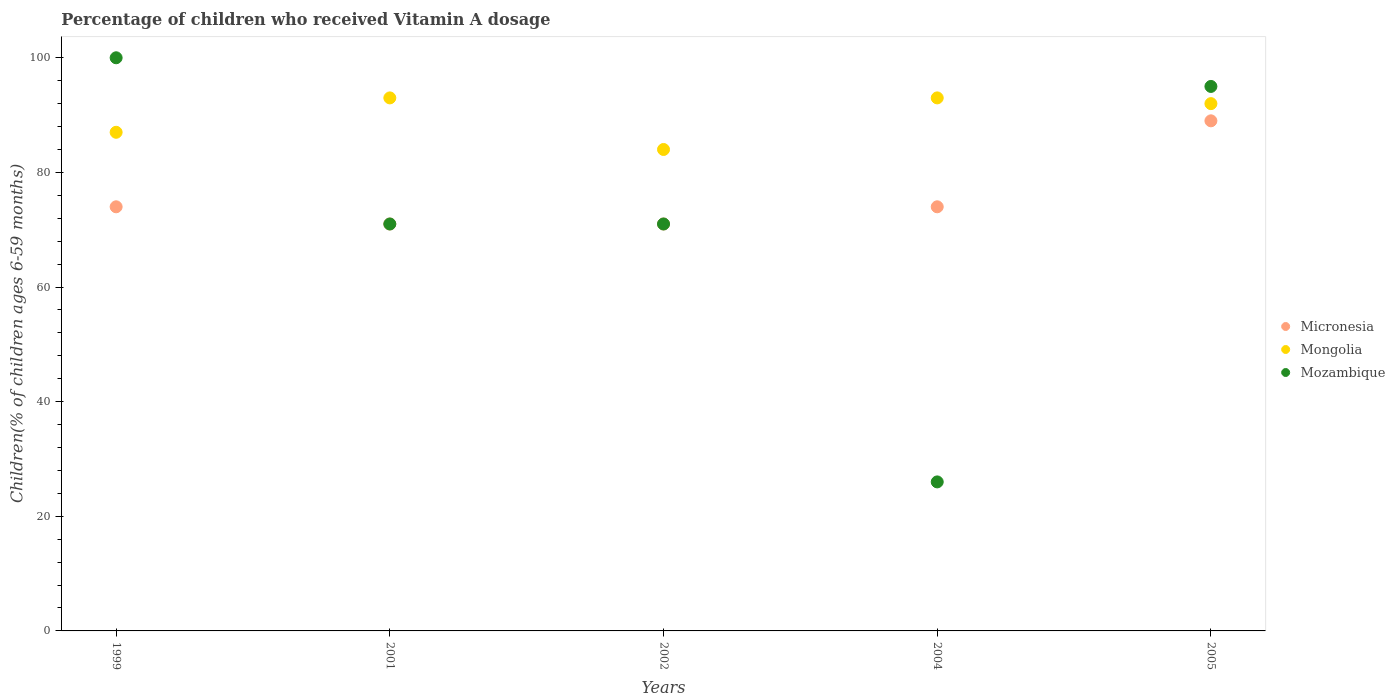Across all years, what is the maximum percentage of children who received Vitamin A dosage in Mongolia?
Ensure brevity in your answer.  93. In which year was the percentage of children who received Vitamin A dosage in Mozambique maximum?
Give a very brief answer. 1999. What is the total percentage of children who received Vitamin A dosage in Mongolia in the graph?
Provide a succinct answer. 449. What is the average percentage of children who received Vitamin A dosage in Mongolia per year?
Keep it short and to the point. 89.8. What is the ratio of the percentage of children who received Vitamin A dosage in Micronesia in 2002 to that in 2005?
Offer a terse response. 0.8. Is the percentage of children who received Vitamin A dosage in Mongolia in 1999 less than that in 2005?
Your answer should be very brief. Yes. Is the difference between the percentage of children who received Vitamin A dosage in Mozambique in 2002 and 2005 greater than the difference between the percentage of children who received Vitamin A dosage in Mongolia in 2002 and 2005?
Your answer should be very brief. No. What is the difference between the highest and the second highest percentage of children who received Vitamin A dosage in Micronesia?
Ensure brevity in your answer.  15. What is the difference between the highest and the lowest percentage of children who received Vitamin A dosage in Mozambique?
Offer a terse response. 74. Does the percentage of children who received Vitamin A dosage in Mongolia monotonically increase over the years?
Keep it short and to the point. No. How many dotlines are there?
Offer a terse response. 3. How many years are there in the graph?
Ensure brevity in your answer.  5. Are the values on the major ticks of Y-axis written in scientific E-notation?
Offer a very short reply. No. Does the graph contain any zero values?
Your answer should be compact. No. How are the legend labels stacked?
Your answer should be very brief. Vertical. What is the title of the graph?
Make the answer very short. Percentage of children who received Vitamin A dosage. Does "Korea (Republic)" appear as one of the legend labels in the graph?
Make the answer very short. No. What is the label or title of the X-axis?
Offer a terse response. Years. What is the label or title of the Y-axis?
Offer a very short reply. Children(% of children ages 6-59 months). What is the Children(% of children ages 6-59 months) of Mozambique in 1999?
Provide a short and direct response. 100. What is the Children(% of children ages 6-59 months) of Mongolia in 2001?
Your answer should be very brief. 93. What is the Children(% of children ages 6-59 months) in Mozambique in 2001?
Offer a terse response. 71. What is the Children(% of children ages 6-59 months) in Micronesia in 2002?
Provide a short and direct response. 71. What is the Children(% of children ages 6-59 months) in Micronesia in 2004?
Your answer should be compact. 74. What is the Children(% of children ages 6-59 months) in Mongolia in 2004?
Keep it short and to the point. 93. What is the Children(% of children ages 6-59 months) in Mozambique in 2004?
Your response must be concise. 26. What is the Children(% of children ages 6-59 months) of Micronesia in 2005?
Give a very brief answer. 89. What is the Children(% of children ages 6-59 months) of Mongolia in 2005?
Make the answer very short. 92. What is the Children(% of children ages 6-59 months) in Mozambique in 2005?
Ensure brevity in your answer.  95. Across all years, what is the maximum Children(% of children ages 6-59 months) of Micronesia?
Your answer should be very brief. 89. Across all years, what is the maximum Children(% of children ages 6-59 months) of Mongolia?
Keep it short and to the point. 93. Across all years, what is the maximum Children(% of children ages 6-59 months) of Mozambique?
Offer a terse response. 100. Across all years, what is the minimum Children(% of children ages 6-59 months) of Micronesia?
Your response must be concise. 71. Across all years, what is the minimum Children(% of children ages 6-59 months) of Mozambique?
Your answer should be very brief. 26. What is the total Children(% of children ages 6-59 months) of Micronesia in the graph?
Your answer should be very brief. 379. What is the total Children(% of children ages 6-59 months) of Mongolia in the graph?
Give a very brief answer. 449. What is the total Children(% of children ages 6-59 months) of Mozambique in the graph?
Ensure brevity in your answer.  363. What is the difference between the Children(% of children ages 6-59 months) in Micronesia in 1999 and that in 2001?
Ensure brevity in your answer.  3. What is the difference between the Children(% of children ages 6-59 months) of Mongolia in 1999 and that in 2001?
Your response must be concise. -6. What is the difference between the Children(% of children ages 6-59 months) of Mozambique in 1999 and that in 2002?
Provide a succinct answer. 29. What is the difference between the Children(% of children ages 6-59 months) of Mongolia in 1999 and that in 2004?
Make the answer very short. -6. What is the difference between the Children(% of children ages 6-59 months) of Mongolia in 1999 and that in 2005?
Offer a terse response. -5. What is the difference between the Children(% of children ages 6-59 months) in Micronesia in 2001 and that in 2002?
Provide a succinct answer. 0. What is the difference between the Children(% of children ages 6-59 months) of Micronesia in 2001 and that in 2004?
Offer a very short reply. -3. What is the difference between the Children(% of children ages 6-59 months) of Mongolia in 2001 and that in 2004?
Your answer should be very brief. 0. What is the difference between the Children(% of children ages 6-59 months) in Micronesia in 2002 and that in 2004?
Keep it short and to the point. -3. What is the difference between the Children(% of children ages 6-59 months) of Mozambique in 2002 and that in 2004?
Provide a short and direct response. 45. What is the difference between the Children(% of children ages 6-59 months) in Micronesia in 2002 and that in 2005?
Provide a short and direct response. -18. What is the difference between the Children(% of children ages 6-59 months) in Mongolia in 2002 and that in 2005?
Give a very brief answer. -8. What is the difference between the Children(% of children ages 6-59 months) of Mozambique in 2004 and that in 2005?
Your answer should be very brief. -69. What is the difference between the Children(% of children ages 6-59 months) in Micronesia in 1999 and the Children(% of children ages 6-59 months) in Mongolia in 2001?
Offer a terse response. -19. What is the difference between the Children(% of children ages 6-59 months) in Micronesia in 1999 and the Children(% of children ages 6-59 months) in Mozambique in 2001?
Give a very brief answer. 3. What is the difference between the Children(% of children ages 6-59 months) in Mongolia in 1999 and the Children(% of children ages 6-59 months) in Mozambique in 2001?
Provide a succinct answer. 16. What is the difference between the Children(% of children ages 6-59 months) of Micronesia in 1999 and the Children(% of children ages 6-59 months) of Mongolia in 2002?
Offer a terse response. -10. What is the difference between the Children(% of children ages 6-59 months) of Mongolia in 1999 and the Children(% of children ages 6-59 months) of Mozambique in 2004?
Provide a succinct answer. 61. What is the difference between the Children(% of children ages 6-59 months) of Micronesia in 1999 and the Children(% of children ages 6-59 months) of Mongolia in 2005?
Provide a short and direct response. -18. What is the difference between the Children(% of children ages 6-59 months) of Micronesia in 2001 and the Children(% of children ages 6-59 months) of Mongolia in 2002?
Keep it short and to the point. -13. What is the difference between the Children(% of children ages 6-59 months) of Micronesia in 2001 and the Children(% of children ages 6-59 months) of Mozambique in 2002?
Give a very brief answer. 0. What is the difference between the Children(% of children ages 6-59 months) of Mongolia in 2001 and the Children(% of children ages 6-59 months) of Mozambique in 2002?
Offer a terse response. 22. What is the difference between the Children(% of children ages 6-59 months) in Micronesia in 2001 and the Children(% of children ages 6-59 months) in Mozambique in 2004?
Provide a succinct answer. 45. What is the difference between the Children(% of children ages 6-59 months) of Micronesia in 2001 and the Children(% of children ages 6-59 months) of Mongolia in 2005?
Give a very brief answer. -21. What is the difference between the Children(% of children ages 6-59 months) in Micronesia in 2001 and the Children(% of children ages 6-59 months) in Mozambique in 2005?
Provide a succinct answer. -24. What is the difference between the Children(% of children ages 6-59 months) in Mongolia in 2001 and the Children(% of children ages 6-59 months) in Mozambique in 2005?
Offer a terse response. -2. What is the difference between the Children(% of children ages 6-59 months) in Micronesia in 2002 and the Children(% of children ages 6-59 months) in Mongolia in 2004?
Make the answer very short. -22. What is the difference between the Children(% of children ages 6-59 months) of Micronesia in 2002 and the Children(% of children ages 6-59 months) of Mongolia in 2005?
Provide a succinct answer. -21. What is the difference between the Children(% of children ages 6-59 months) in Mongolia in 2002 and the Children(% of children ages 6-59 months) in Mozambique in 2005?
Give a very brief answer. -11. What is the average Children(% of children ages 6-59 months) of Micronesia per year?
Provide a succinct answer. 75.8. What is the average Children(% of children ages 6-59 months) in Mongolia per year?
Your response must be concise. 89.8. What is the average Children(% of children ages 6-59 months) in Mozambique per year?
Your answer should be compact. 72.6. In the year 2001, what is the difference between the Children(% of children ages 6-59 months) in Micronesia and Children(% of children ages 6-59 months) in Mongolia?
Your answer should be compact. -22. In the year 2001, what is the difference between the Children(% of children ages 6-59 months) in Mongolia and Children(% of children ages 6-59 months) in Mozambique?
Make the answer very short. 22. In the year 2002, what is the difference between the Children(% of children ages 6-59 months) in Micronesia and Children(% of children ages 6-59 months) in Mozambique?
Make the answer very short. 0. In the year 2004, what is the difference between the Children(% of children ages 6-59 months) of Micronesia and Children(% of children ages 6-59 months) of Mozambique?
Your answer should be very brief. 48. In the year 2004, what is the difference between the Children(% of children ages 6-59 months) of Mongolia and Children(% of children ages 6-59 months) of Mozambique?
Your response must be concise. 67. In the year 2005, what is the difference between the Children(% of children ages 6-59 months) in Micronesia and Children(% of children ages 6-59 months) in Mongolia?
Give a very brief answer. -3. In the year 2005, what is the difference between the Children(% of children ages 6-59 months) in Mongolia and Children(% of children ages 6-59 months) in Mozambique?
Ensure brevity in your answer.  -3. What is the ratio of the Children(% of children ages 6-59 months) in Micronesia in 1999 to that in 2001?
Your response must be concise. 1.04. What is the ratio of the Children(% of children ages 6-59 months) of Mongolia in 1999 to that in 2001?
Offer a very short reply. 0.94. What is the ratio of the Children(% of children ages 6-59 months) in Mozambique in 1999 to that in 2001?
Your answer should be very brief. 1.41. What is the ratio of the Children(% of children ages 6-59 months) of Micronesia in 1999 to that in 2002?
Offer a very short reply. 1.04. What is the ratio of the Children(% of children ages 6-59 months) of Mongolia in 1999 to that in 2002?
Keep it short and to the point. 1.04. What is the ratio of the Children(% of children ages 6-59 months) of Mozambique in 1999 to that in 2002?
Your answer should be very brief. 1.41. What is the ratio of the Children(% of children ages 6-59 months) of Micronesia in 1999 to that in 2004?
Keep it short and to the point. 1. What is the ratio of the Children(% of children ages 6-59 months) in Mongolia in 1999 to that in 2004?
Your answer should be compact. 0.94. What is the ratio of the Children(% of children ages 6-59 months) in Mozambique in 1999 to that in 2004?
Your response must be concise. 3.85. What is the ratio of the Children(% of children ages 6-59 months) in Micronesia in 1999 to that in 2005?
Give a very brief answer. 0.83. What is the ratio of the Children(% of children ages 6-59 months) of Mongolia in 1999 to that in 2005?
Your response must be concise. 0.95. What is the ratio of the Children(% of children ages 6-59 months) of Mozambique in 1999 to that in 2005?
Give a very brief answer. 1.05. What is the ratio of the Children(% of children ages 6-59 months) of Micronesia in 2001 to that in 2002?
Offer a very short reply. 1. What is the ratio of the Children(% of children ages 6-59 months) of Mongolia in 2001 to that in 2002?
Keep it short and to the point. 1.11. What is the ratio of the Children(% of children ages 6-59 months) in Mozambique in 2001 to that in 2002?
Keep it short and to the point. 1. What is the ratio of the Children(% of children ages 6-59 months) in Micronesia in 2001 to that in 2004?
Offer a very short reply. 0.96. What is the ratio of the Children(% of children ages 6-59 months) in Mongolia in 2001 to that in 2004?
Provide a succinct answer. 1. What is the ratio of the Children(% of children ages 6-59 months) of Mozambique in 2001 to that in 2004?
Your response must be concise. 2.73. What is the ratio of the Children(% of children ages 6-59 months) in Micronesia in 2001 to that in 2005?
Provide a short and direct response. 0.8. What is the ratio of the Children(% of children ages 6-59 months) in Mongolia in 2001 to that in 2005?
Give a very brief answer. 1.01. What is the ratio of the Children(% of children ages 6-59 months) in Mozambique in 2001 to that in 2005?
Ensure brevity in your answer.  0.75. What is the ratio of the Children(% of children ages 6-59 months) of Micronesia in 2002 to that in 2004?
Provide a succinct answer. 0.96. What is the ratio of the Children(% of children ages 6-59 months) in Mongolia in 2002 to that in 2004?
Make the answer very short. 0.9. What is the ratio of the Children(% of children ages 6-59 months) of Mozambique in 2002 to that in 2004?
Your answer should be compact. 2.73. What is the ratio of the Children(% of children ages 6-59 months) in Micronesia in 2002 to that in 2005?
Provide a short and direct response. 0.8. What is the ratio of the Children(% of children ages 6-59 months) of Mozambique in 2002 to that in 2005?
Give a very brief answer. 0.75. What is the ratio of the Children(% of children ages 6-59 months) of Micronesia in 2004 to that in 2005?
Provide a succinct answer. 0.83. What is the ratio of the Children(% of children ages 6-59 months) in Mongolia in 2004 to that in 2005?
Give a very brief answer. 1.01. What is the ratio of the Children(% of children ages 6-59 months) of Mozambique in 2004 to that in 2005?
Make the answer very short. 0.27. What is the difference between the highest and the second highest Children(% of children ages 6-59 months) in Mongolia?
Your answer should be very brief. 0. 